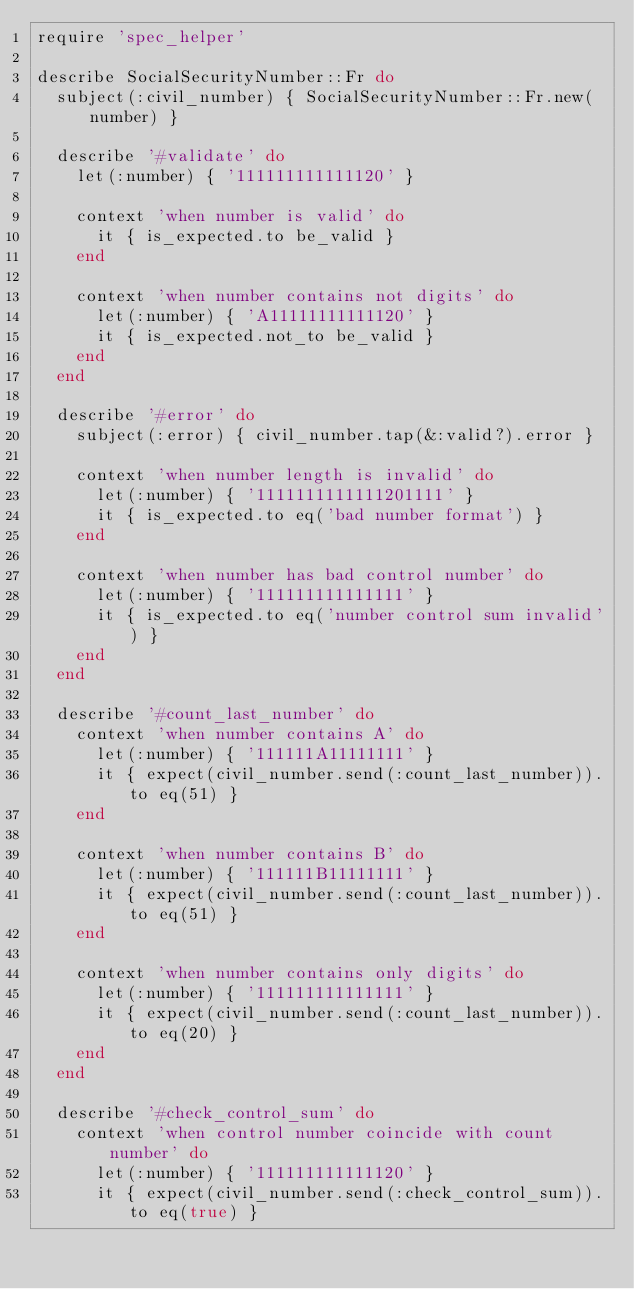<code> <loc_0><loc_0><loc_500><loc_500><_Ruby_>require 'spec_helper'

describe SocialSecurityNumber::Fr do
  subject(:civil_number) { SocialSecurityNumber::Fr.new(number) }

  describe '#validate' do
    let(:number) { '111111111111120' }

    context 'when number is valid' do
      it { is_expected.to be_valid }
    end

    context 'when number contains not digits' do
      let(:number) { 'A11111111111120' }
      it { is_expected.not_to be_valid }
    end
  end

  describe '#error' do
    subject(:error) { civil_number.tap(&:valid?).error }

    context 'when number length is invalid' do
      let(:number) { '1111111111111201111' }
      it { is_expected.to eq('bad number format') }
    end

    context 'when number has bad control number' do
      let(:number) { '111111111111111' }
      it { is_expected.to eq('number control sum invalid') }
    end
  end

  describe '#count_last_number' do
    context 'when number contains A' do
      let(:number) { '111111A11111111' }
      it { expect(civil_number.send(:count_last_number)).to eq(51) }
    end

    context 'when number contains B' do
      let(:number) { '111111B11111111' }
      it { expect(civil_number.send(:count_last_number)).to eq(51) }
    end

    context 'when number contains only digits' do
      let(:number) { '111111111111111' }
      it { expect(civil_number.send(:count_last_number)).to eq(20) }
    end
  end

  describe '#check_control_sum' do
    context 'when control number coincide with count number' do
      let(:number) { '111111111111120' }
      it { expect(civil_number.send(:check_control_sum)).to eq(true) }</code> 